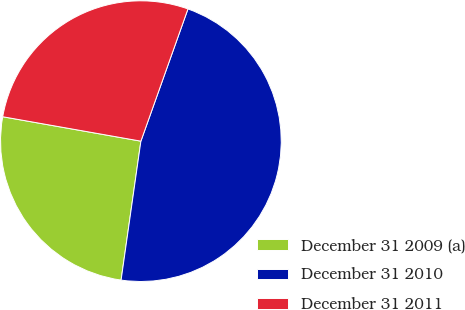Convert chart to OTSL. <chart><loc_0><loc_0><loc_500><loc_500><pie_chart><fcel>December 31 2009 (a)<fcel>December 31 2010<fcel>December 31 2011<nl><fcel>25.53%<fcel>46.81%<fcel>27.66%<nl></chart> 